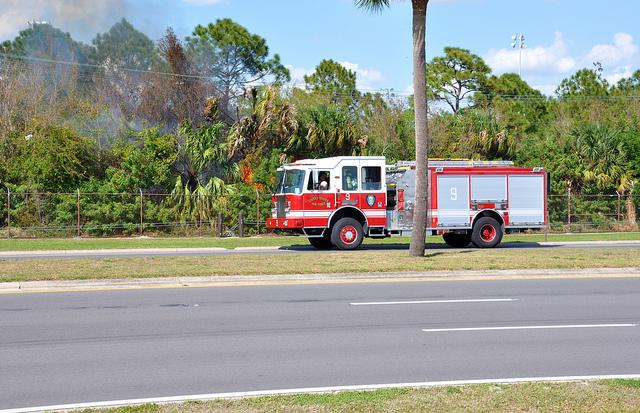Is there an apparent reason for the vehicle being where it's at?
Short answer required. Yes. How many trees are in front on the fire truck?
Be succinct. 1. Is there a fire in the picture?
Keep it brief. Yes. Is there something burning?
Write a very short answer. Yes. Is there a stop sign?
Be succinct. No. 